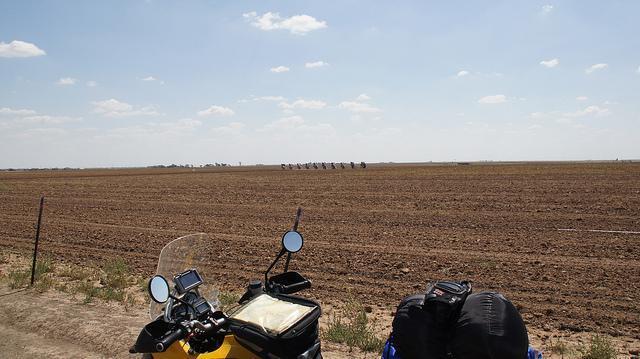How many mirrors are there?
Give a very brief answer. 2. How many motorcycles are in the photo?
Give a very brief answer. 1. How many backpacks are in the picture?
Give a very brief answer. 2. 